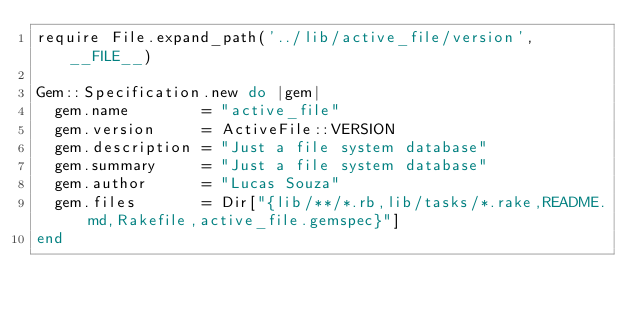Convert code to text. <code><loc_0><loc_0><loc_500><loc_500><_Ruby_>require File.expand_path('../lib/active_file/version', __FILE__)

Gem::Specification.new do |gem|
  gem.name        = "active_file"
  gem.version     = ActiveFile::VERSION
  gem.description = "Just a file system database"
  gem.summary     = "Just a file system database"
  gem.author      = "Lucas Souza"
  gem.files       = Dir["{lib/**/*.rb,lib/tasks/*.rake,README.md,Rakefile,active_file.gemspec}"]
end

</code> 